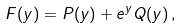Convert formula to latex. <formula><loc_0><loc_0><loc_500><loc_500>F ( y ) = P ( y ) + e ^ { y } Q ( y ) \, ,</formula> 